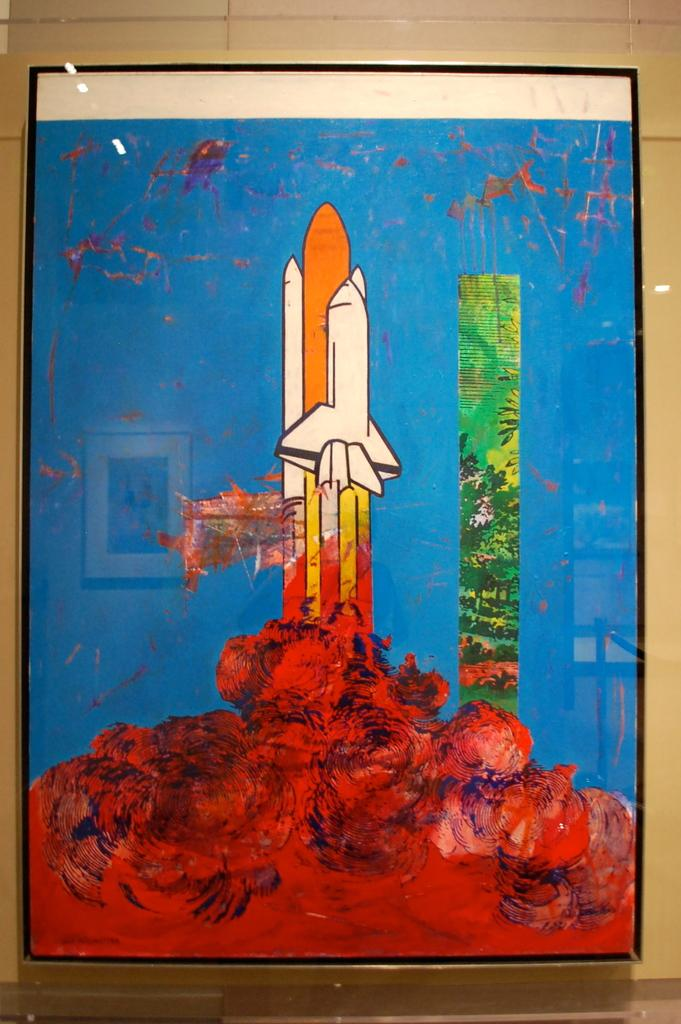What is the main subject of the painting in the image? The painting depicts a plane. Are there any other elements in the painting besides the plane? Yes, the painting includes other elements in different colors. What type of scale is used by the farmer in the painting? There is no farmer or scale present in the painting; it depicts a plane and other elements in different colors. 